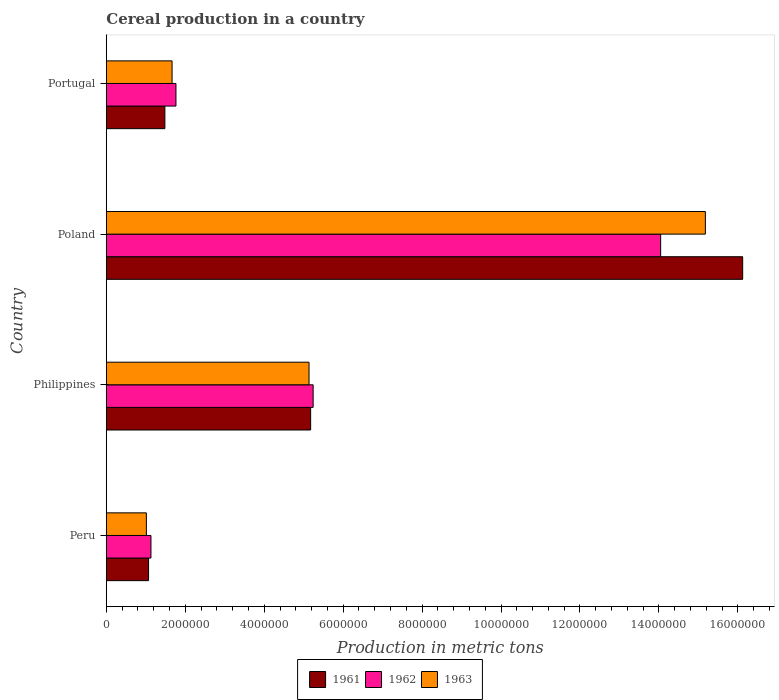What is the label of the 3rd group of bars from the top?
Your answer should be compact. Philippines. What is the total cereal production in 1962 in Philippines?
Your answer should be very brief. 5.24e+06. Across all countries, what is the maximum total cereal production in 1963?
Your answer should be compact. 1.52e+07. Across all countries, what is the minimum total cereal production in 1963?
Offer a terse response. 1.01e+06. In which country was the total cereal production in 1962 minimum?
Provide a short and direct response. Peru. What is the total total cereal production in 1961 in the graph?
Offer a terse response. 2.39e+07. What is the difference between the total cereal production in 1961 in Peru and that in Poland?
Provide a succinct answer. -1.51e+07. What is the difference between the total cereal production in 1962 in Peru and the total cereal production in 1961 in Philippines?
Give a very brief answer. -4.05e+06. What is the average total cereal production in 1962 per country?
Make the answer very short. 5.54e+06. What is the difference between the total cereal production in 1963 and total cereal production in 1962 in Philippines?
Your answer should be compact. -1.04e+05. In how many countries, is the total cereal production in 1963 greater than 13600000 metric tons?
Your answer should be compact. 1. What is the ratio of the total cereal production in 1962 in Peru to that in Poland?
Offer a terse response. 0.08. What is the difference between the highest and the second highest total cereal production in 1962?
Offer a terse response. 8.81e+06. What is the difference between the highest and the lowest total cereal production in 1963?
Make the answer very short. 1.42e+07. Is the sum of the total cereal production in 1961 in Peru and Portugal greater than the maximum total cereal production in 1962 across all countries?
Keep it short and to the point. No. What does the 3rd bar from the bottom in Philippines represents?
Provide a succinct answer. 1963. How many countries are there in the graph?
Provide a short and direct response. 4. What is the difference between two consecutive major ticks on the X-axis?
Give a very brief answer. 2.00e+06. Where does the legend appear in the graph?
Your answer should be very brief. Bottom center. How many legend labels are there?
Give a very brief answer. 3. How are the legend labels stacked?
Make the answer very short. Horizontal. What is the title of the graph?
Provide a succinct answer. Cereal production in a country. Does "1961" appear as one of the legend labels in the graph?
Offer a terse response. Yes. What is the label or title of the X-axis?
Your answer should be very brief. Production in metric tons. What is the Production in metric tons in 1961 in Peru?
Make the answer very short. 1.07e+06. What is the Production in metric tons of 1962 in Peru?
Provide a succinct answer. 1.13e+06. What is the Production in metric tons of 1963 in Peru?
Make the answer very short. 1.01e+06. What is the Production in metric tons in 1961 in Philippines?
Offer a terse response. 5.18e+06. What is the Production in metric tons in 1962 in Philippines?
Give a very brief answer. 5.24e+06. What is the Production in metric tons in 1963 in Philippines?
Give a very brief answer. 5.14e+06. What is the Production in metric tons of 1961 in Poland?
Offer a terse response. 1.61e+07. What is the Production in metric tons of 1962 in Poland?
Your answer should be very brief. 1.40e+07. What is the Production in metric tons of 1963 in Poland?
Your answer should be very brief. 1.52e+07. What is the Production in metric tons in 1961 in Portugal?
Provide a short and direct response. 1.48e+06. What is the Production in metric tons of 1962 in Portugal?
Provide a short and direct response. 1.76e+06. What is the Production in metric tons of 1963 in Portugal?
Your answer should be compact. 1.67e+06. Across all countries, what is the maximum Production in metric tons of 1961?
Ensure brevity in your answer.  1.61e+07. Across all countries, what is the maximum Production in metric tons of 1962?
Ensure brevity in your answer.  1.40e+07. Across all countries, what is the maximum Production in metric tons of 1963?
Keep it short and to the point. 1.52e+07. Across all countries, what is the minimum Production in metric tons of 1961?
Your answer should be very brief. 1.07e+06. Across all countries, what is the minimum Production in metric tons in 1962?
Give a very brief answer. 1.13e+06. Across all countries, what is the minimum Production in metric tons in 1963?
Keep it short and to the point. 1.01e+06. What is the total Production in metric tons of 1961 in the graph?
Offer a terse response. 2.39e+07. What is the total Production in metric tons in 1962 in the graph?
Your answer should be compact. 2.22e+07. What is the total Production in metric tons of 1963 in the graph?
Keep it short and to the point. 2.30e+07. What is the difference between the Production in metric tons in 1961 in Peru and that in Philippines?
Make the answer very short. -4.11e+06. What is the difference between the Production in metric tons of 1962 in Peru and that in Philippines?
Keep it short and to the point. -4.11e+06. What is the difference between the Production in metric tons in 1963 in Peru and that in Philippines?
Ensure brevity in your answer.  -4.12e+06. What is the difference between the Production in metric tons in 1961 in Peru and that in Poland?
Offer a very short reply. -1.51e+07. What is the difference between the Production in metric tons in 1962 in Peru and that in Poland?
Keep it short and to the point. -1.29e+07. What is the difference between the Production in metric tons in 1963 in Peru and that in Poland?
Give a very brief answer. -1.42e+07. What is the difference between the Production in metric tons in 1961 in Peru and that in Portugal?
Offer a terse response. -4.13e+05. What is the difference between the Production in metric tons of 1962 in Peru and that in Portugal?
Make the answer very short. -6.33e+05. What is the difference between the Production in metric tons in 1963 in Peru and that in Portugal?
Provide a succinct answer. -6.51e+05. What is the difference between the Production in metric tons of 1961 in Philippines and that in Poland?
Your answer should be very brief. -1.09e+07. What is the difference between the Production in metric tons of 1962 in Philippines and that in Poland?
Keep it short and to the point. -8.81e+06. What is the difference between the Production in metric tons in 1963 in Philippines and that in Poland?
Offer a terse response. -1.00e+07. What is the difference between the Production in metric tons in 1961 in Philippines and that in Portugal?
Offer a very short reply. 3.69e+06. What is the difference between the Production in metric tons of 1962 in Philippines and that in Portugal?
Your answer should be very brief. 3.48e+06. What is the difference between the Production in metric tons of 1963 in Philippines and that in Portugal?
Give a very brief answer. 3.47e+06. What is the difference between the Production in metric tons of 1961 in Poland and that in Portugal?
Keep it short and to the point. 1.46e+07. What is the difference between the Production in metric tons in 1962 in Poland and that in Portugal?
Provide a short and direct response. 1.23e+07. What is the difference between the Production in metric tons of 1963 in Poland and that in Portugal?
Your answer should be very brief. 1.35e+07. What is the difference between the Production in metric tons in 1961 in Peru and the Production in metric tons in 1962 in Philippines?
Provide a short and direct response. -4.17e+06. What is the difference between the Production in metric tons in 1961 in Peru and the Production in metric tons in 1963 in Philippines?
Your answer should be compact. -4.07e+06. What is the difference between the Production in metric tons of 1962 in Peru and the Production in metric tons of 1963 in Philippines?
Offer a terse response. -4.00e+06. What is the difference between the Production in metric tons in 1961 in Peru and the Production in metric tons in 1962 in Poland?
Keep it short and to the point. -1.30e+07. What is the difference between the Production in metric tons of 1961 in Peru and the Production in metric tons of 1963 in Poland?
Make the answer very short. -1.41e+07. What is the difference between the Production in metric tons in 1962 in Peru and the Production in metric tons in 1963 in Poland?
Offer a very short reply. -1.40e+07. What is the difference between the Production in metric tons in 1961 in Peru and the Production in metric tons in 1962 in Portugal?
Give a very brief answer. -6.94e+05. What is the difference between the Production in metric tons in 1961 in Peru and the Production in metric tons in 1963 in Portugal?
Your answer should be very brief. -5.95e+05. What is the difference between the Production in metric tons in 1962 in Peru and the Production in metric tons in 1963 in Portugal?
Make the answer very short. -5.35e+05. What is the difference between the Production in metric tons in 1961 in Philippines and the Production in metric tons in 1962 in Poland?
Make the answer very short. -8.87e+06. What is the difference between the Production in metric tons in 1961 in Philippines and the Production in metric tons in 1963 in Poland?
Offer a very short reply. -1.00e+07. What is the difference between the Production in metric tons of 1962 in Philippines and the Production in metric tons of 1963 in Poland?
Your answer should be compact. -9.94e+06. What is the difference between the Production in metric tons in 1961 in Philippines and the Production in metric tons in 1962 in Portugal?
Make the answer very short. 3.41e+06. What is the difference between the Production in metric tons of 1961 in Philippines and the Production in metric tons of 1963 in Portugal?
Give a very brief answer. 3.51e+06. What is the difference between the Production in metric tons in 1962 in Philippines and the Production in metric tons in 1963 in Portugal?
Offer a terse response. 3.57e+06. What is the difference between the Production in metric tons in 1961 in Poland and the Production in metric tons in 1962 in Portugal?
Provide a succinct answer. 1.44e+07. What is the difference between the Production in metric tons in 1961 in Poland and the Production in metric tons in 1963 in Portugal?
Give a very brief answer. 1.45e+07. What is the difference between the Production in metric tons of 1962 in Poland and the Production in metric tons of 1963 in Portugal?
Provide a short and direct response. 1.24e+07. What is the average Production in metric tons of 1961 per country?
Make the answer very short. 5.96e+06. What is the average Production in metric tons of 1962 per country?
Ensure brevity in your answer.  5.54e+06. What is the average Production in metric tons in 1963 per country?
Keep it short and to the point. 5.75e+06. What is the difference between the Production in metric tons in 1961 and Production in metric tons in 1962 in Peru?
Offer a terse response. -6.05e+04. What is the difference between the Production in metric tons in 1961 and Production in metric tons in 1963 in Peru?
Ensure brevity in your answer.  5.57e+04. What is the difference between the Production in metric tons in 1962 and Production in metric tons in 1963 in Peru?
Your response must be concise. 1.16e+05. What is the difference between the Production in metric tons in 1961 and Production in metric tons in 1962 in Philippines?
Give a very brief answer. -6.35e+04. What is the difference between the Production in metric tons of 1961 and Production in metric tons of 1963 in Philippines?
Keep it short and to the point. 4.08e+04. What is the difference between the Production in metric tons of 1962 and Production in metric tons of 1963 in Philippines?
Offer a terse response. 1.04e+05. What is the difference between the Production in metric tons in 1961 and Production in metric tons in 1962 in Poland?
Offer a terse response. 2.08e+06. What is the difference between the Production in metric tons of 1961 and Production in metric tons of 1963 in Poland?
Provide a succinct answer. 9.45e+05. What is the difference between the Production in metric tons in 1962 and Production in metric tons in 1963 in Poland?
Give a very brief answer. -1.13e+06. What is the difference between the Production in metric tons in 1961 and Production in metric tons in 1962 in Portugal?
Provide a short and direct response. -2.81e+05. What is the difference between the Production in metric tons of 1961 and Production in metric tons of 1963 in Portugal?
Your answer should be compact. -1.82e+05. What is the difference between the Production in metric tons in 1962 and Production in metric tons in 1963 in Portugal?
Provide a succinct answer. 9.87e+04. What is the ratio of the Production in metric tons of 1961 in Peru to that in Philippines?
Offer a very short reply. 0.21. What is the ratio of the Production in metric tons in 1962 in Peru to that in Philippines?
Give a very brief answer. 0.22. What is the ratio of the Production in metric tons in 1963 in Peru to that in Philippines?
Your answer should be very brief. 0.2. What is the ratio of the Production in metric tons in 1961 in Peru to that in Poland?
Offer a very short reply. 0.07. What is the ratio of the Production in metric tons in 1962 in Peru to that in Poland?
Keep it short and to the point. 0.08. What is the ratio of the Production in metric tons in 1963 in Peru to that in Poland?
Keep it short and to the point. 0.07. What is the ratio of the Production in metric tons of 1961 in Peru to that in Portugal?
Provide a short and direct response. 0.72. What is the ratio of the Production in metric tons in 1962 in Peru to that in Portugal?
Offer a terse response. 0.64. What is the ratio of the Production in metric tons in 1963 in Peru to that in Portugal?
Provide a succinct answer. 0.61. What is the ratio of the Production in metric tons in 1961 in Philippines to that in Poland?
Your response must be concise. 0.32. What is the ratio of the Production in metric tons in 1962 in Philippines to that in Poland?
Make the answer very short. 0.37. What is the ratio of the Production in metric tons of 1963 in Philippines to that in Poland?
Keep it short and to the point. 0.34. What is the ratio of the Production in metric tons in 1961 in Philippines to that in Portugal?
Your response must be concise. 3.49. What is the ratio of the Production in metric tons in 1962 in Philippines to that in Portugal?
Make the answer very short. 2.97. What is the ratio of the Production in metric tons in 1963 in Philippines to that in Portugal?
Your answer should be very brief. 3.08. What is the ratio of the Production in metric tons in 1961 in Poland to that in Portugal?
Make the answer very short. 10.87. What is the ratio of the Production in metric tons of 1962 in Poland to that in Portugal?
Give a very brief answer. 7.96. What is the ratio of the Production in metric tons of 1963 in Poland to that in Portugal?
Make the answer very short. 9.11. What is the difference between the highest and the second highest Production in metric tons in 1961?
Make the answer very short. 1.09e+07. What is the difference between the highest and the second highest Production in metric tons of 1962?
Provide a succinct answer. 8.81e+06. What is the difference between the highest and the second highest Production in metric tons in 1963?
Give a very brief answer. 1.00e+07. What is the difference between the highest and the lowest Production in metric tons in 1961?
Your answer should be compact. 1.51e+07. What is the difference between the highest and the lowest Production in metric tons in 1962?
Offer a terse response. 1.29e+07. What is the difference between the highest and the lowest Production in metric tons in 1963?
Provide a short and direct response. 1.42e+07. 